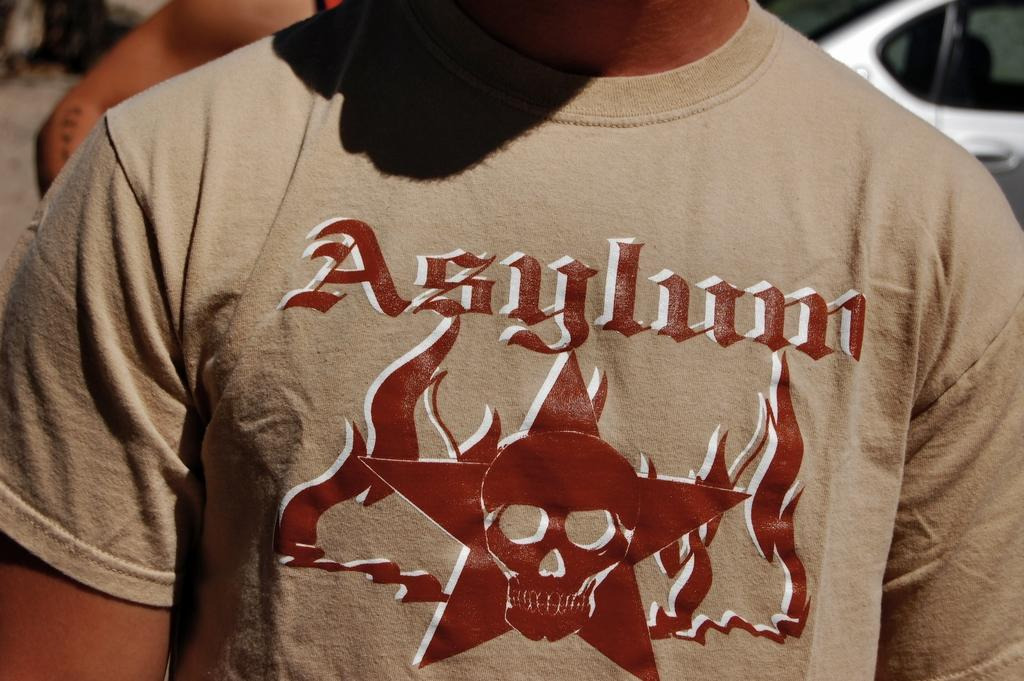<image>
Create a compact narrative representing the image presented. A closeup of a man wearing a t-shirt that reads Asylum over an image of a skull in the middle of a star. 